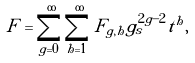Convert formula to latex. <formula><loc_0><loc_0><loc_500><loc_500>F = \sum _ { g = 0 } ^ { \infty } \sum _ { h = 1 } ^ { \infty } F _ { g , h } g _ { s } ^ { 2 g - 2 } t ^ { h } ,</formula> 